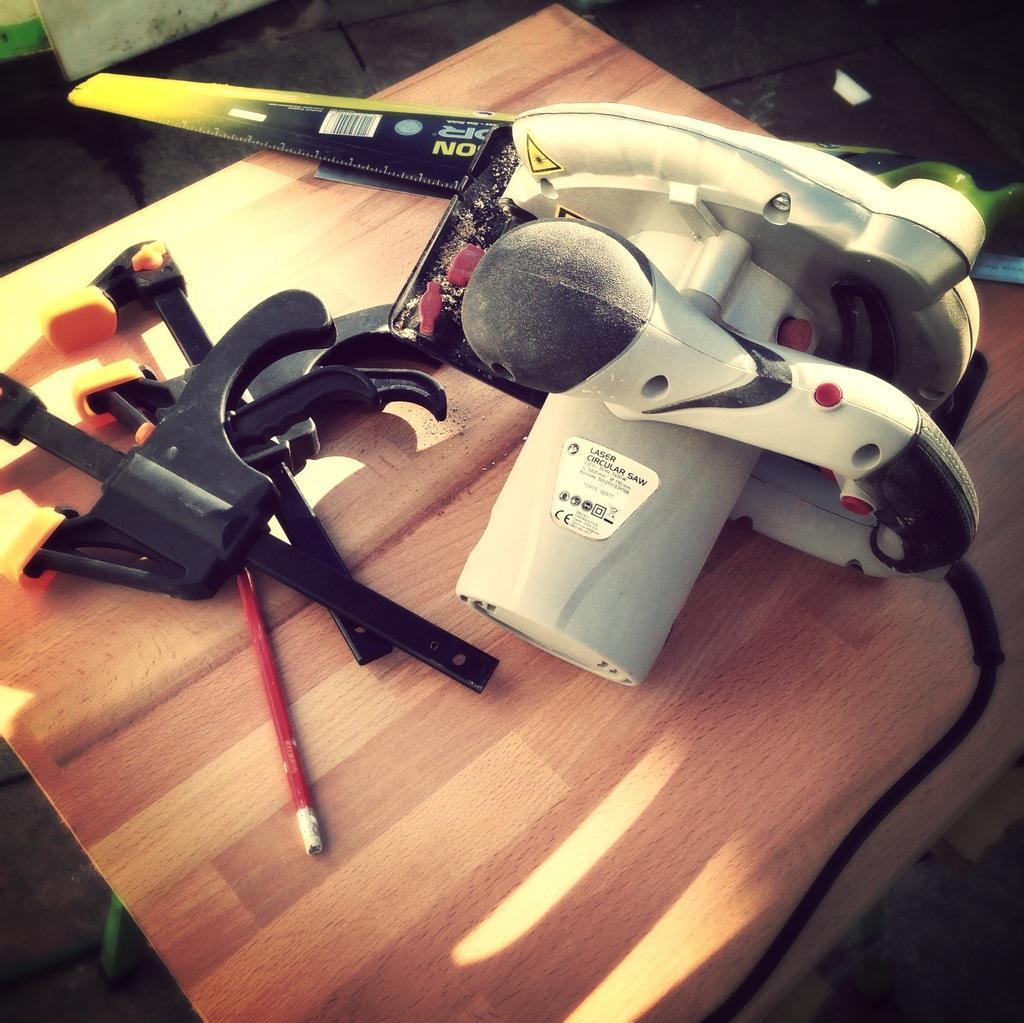Could you give a brief overview of what you see in this image? In this picture I can see few things on the brown color surface and I can see stickers on which there is something written. 